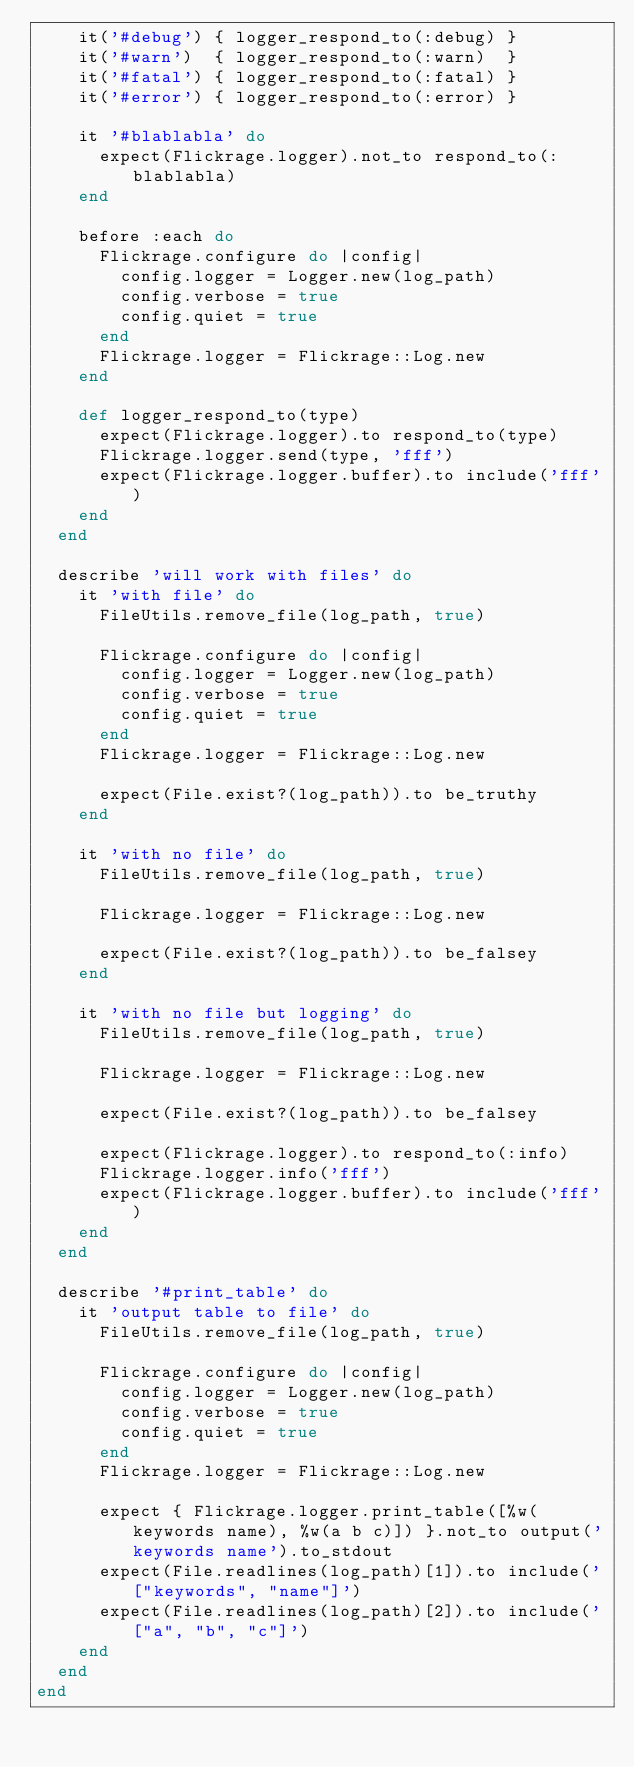<code> <loc_0><loc_0><loc_500><loc_500><_Ruby_>    it('#debug') { logger_respond_to(:debug) }
    it('#warn')  { logger_respond_to(:warn)  }
    it('#fatal') { logger_respond_to(:fatal) }
    it('#error') { logger_respond_to(:error) }

    it '#blablabla' do
      expect(Flickrage.logger).not_to respond_to(:blablabla)
    end

    before :each do
      Flickrage.configure do |config|
        config.logger = Logger.new(log_path)
        config.verbose = true
        config.quiet = true
      end
      Flickrage.logger = Flickrage::Log.new
    end

    def logger_respond_to(type)
      expect(Flickrage.logger).to respond_to(type)
      Flickrage.logger.send(type, 'fff')
      expect(Flickrage.logger.buffer).to include('fff')
    end
  end

  describe 'will work with files' do
    it 'with file' do
      FileUtils.remove_file(log_path, true)

      Flickrage.configure do |config|
        config.logger = Logger.new(log_path)
        config.verbose = true
        config.quiet = true
      end
      Flickrage.logger = Flickrage::Log.new

      expect(File.exist?(log_path)).to be_truthy
    end

    it 'with no file' do
      FileUtils.remove_file(log_path, true)

      Flickrage.logger = Flickrage::Log.new

      expect(File.exist?(log_path)).to be_falsey
    end

    it 'with no file but logging' do
      FileUtils.remove_file(log_path, true)

      Flickrage.logger = Flickrage::Log.new

      expect(File.exist?(log_path)).to be_falsey

      expect(Flickrage.logger).to respond_to(:info)
      Flickrage.logger.info('fff')
      expect(Flickrage.logger.buffer).to include('fff')
    end
  end

  describe '#print_table' do
    it 'output table to file' do
      FileUtils.remove_file(log_path, true)

      Flickrage.configure do |config|
        config.logger = Logger.new(log_path)
        config.verbose = true
        config.quiet = true
      end
      Flickrage.logger = Flickrage::Log.new

      expect { Flickrage.logger.print_table([%w(keywords name), %w(a b c)]) }.not_to output('keywords name').to_stdout
      expect(File.readlines(log_path)[1]).to include('["keywords", "name"]')
      expect(File.readlines(log_path)[2]).to include('["a", "b", "c"]')
    end
  end
end
</code> 